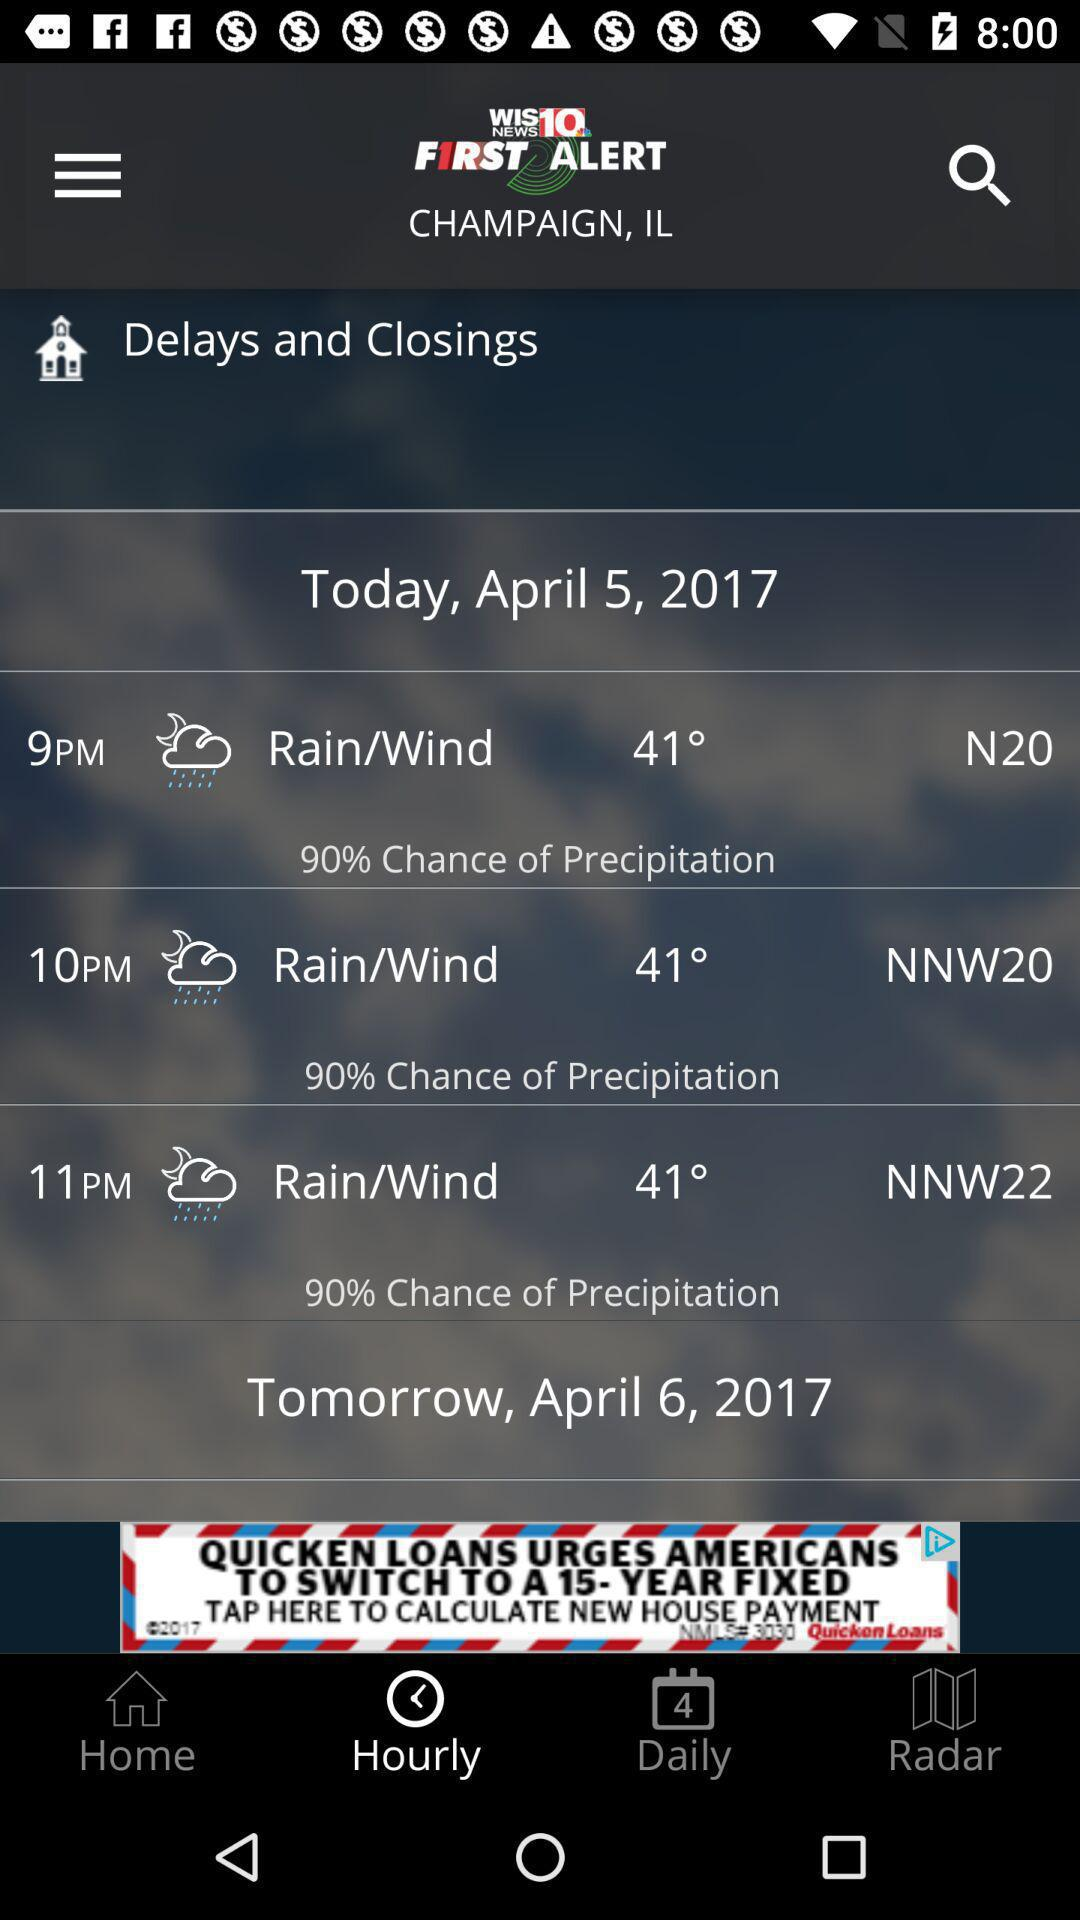How many days are predicted?
Answer the question using a single word or phrase. 2 